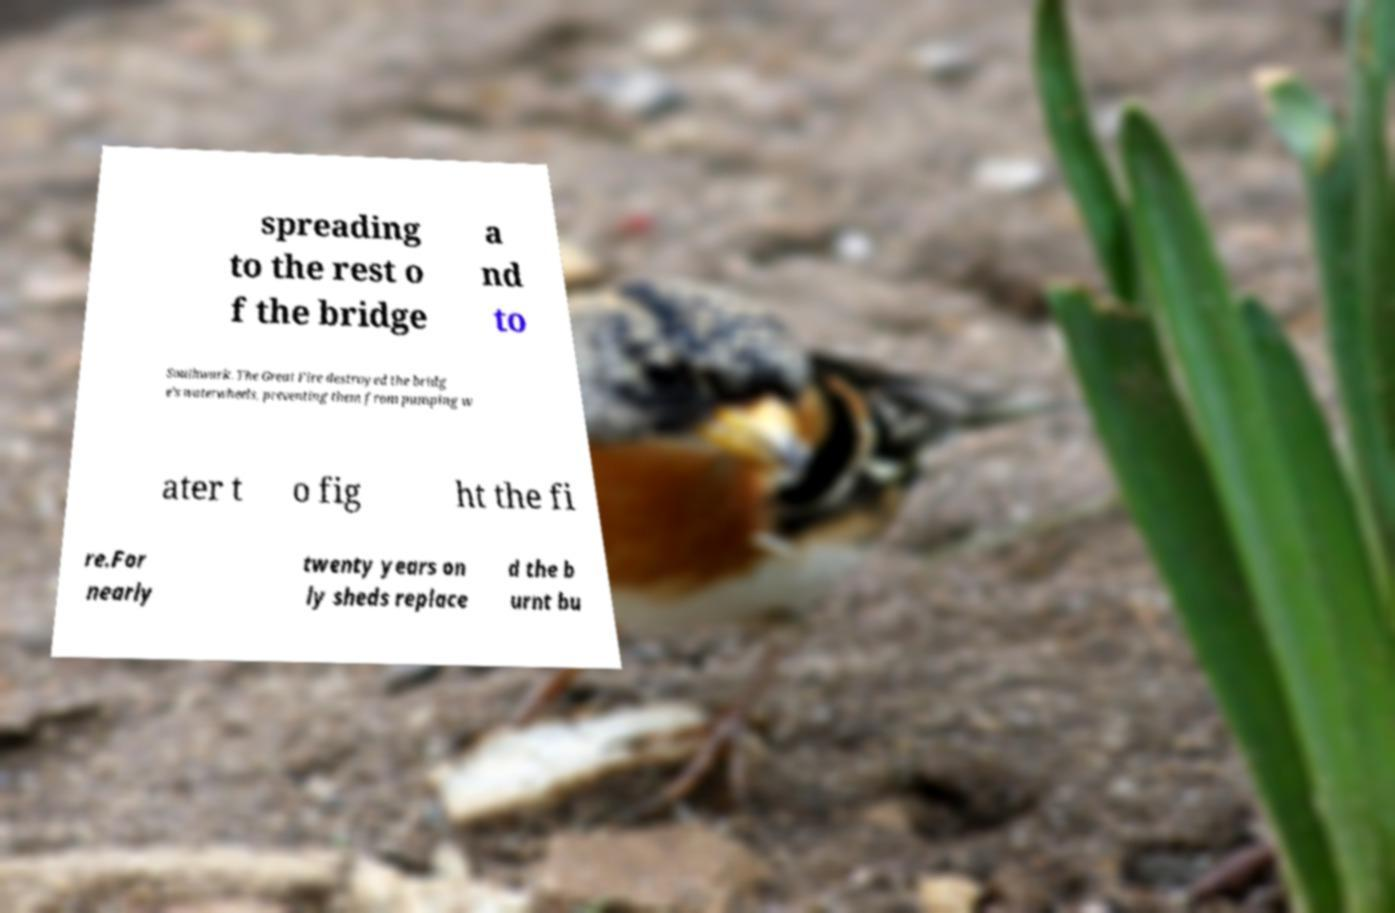What messages or text are displayed in this image? I need them in a readable, typed format. spreading to the rest o f the bridge a nd to Southwark. The Great Fire destroyed the bridg e's waterwheels, preventing them from pumping w ater t o fig ht the fi re.For nearly twenty years on ly sheds replace d the b urnt bu 